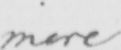Please transcribe the handwritten text in this image. mere 